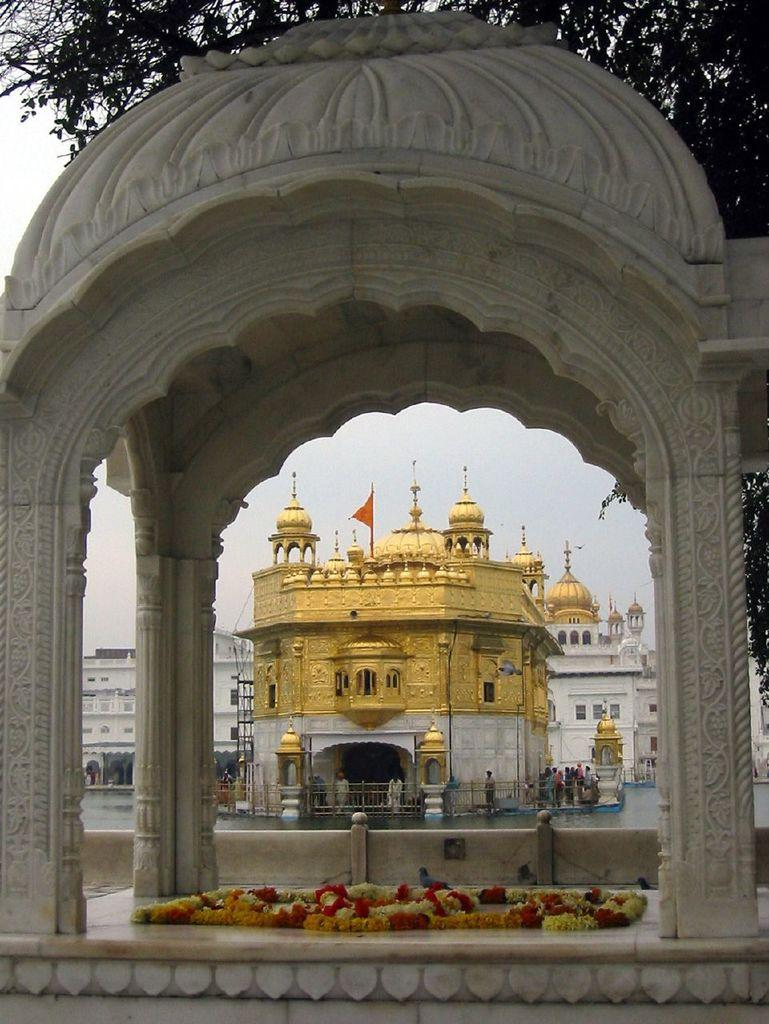What type of structures can be seen in the image? There are buildings in the image. What natural feature is present in the image? There is a water body in the image. What type of plants are visible in the image? There are flowers in the image. What is visible in the background of the image? The sky is visible in the image. What type of vegetation is at the top of the image? There is a tree at the top of the image. What type of soda is being poured into the water body in the image? There is no soda present in the image; it features buildings, a water body, flowers, the sky, and a tree. What type of ray is flying over the tree in the image? There is no ray present in the image; it only features buildings, a water body, flowers, the sky, and a tree. 